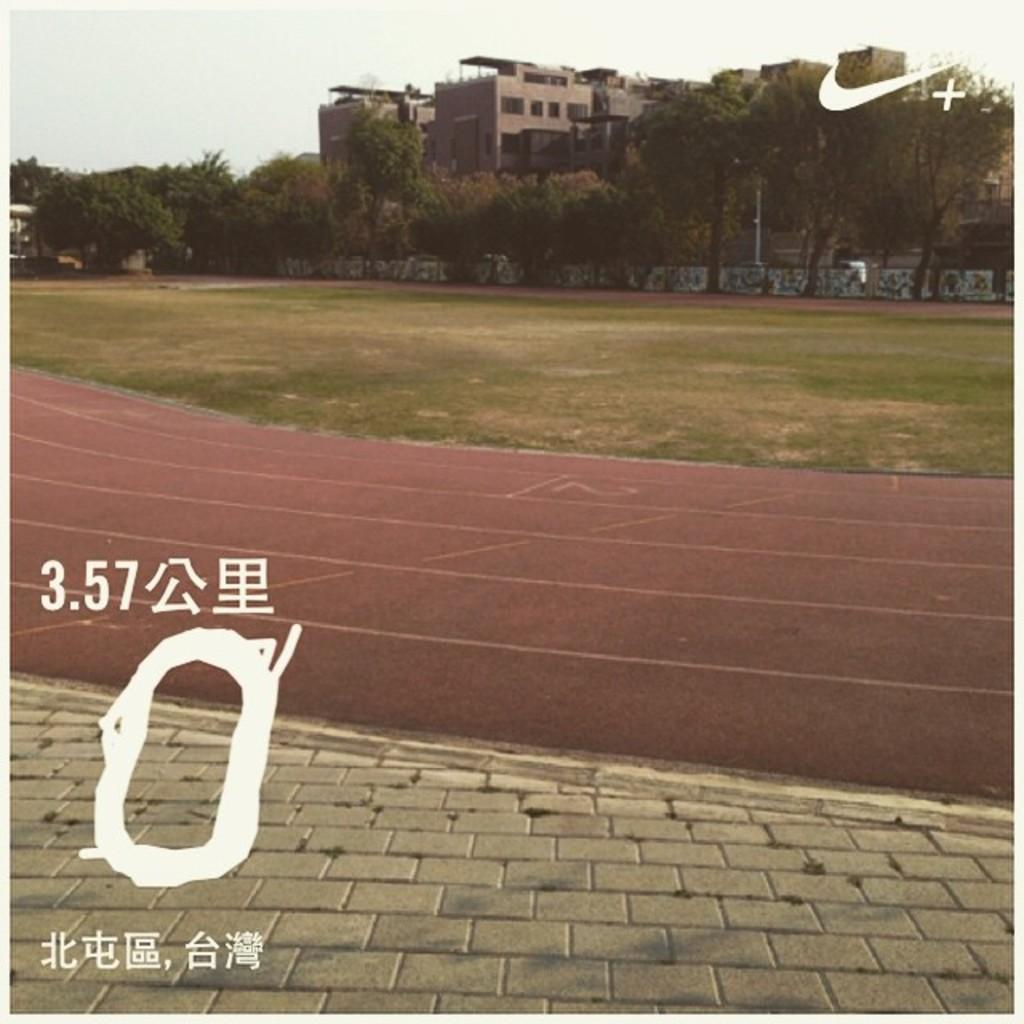What type of pathway is present in the image? There is a road in the image. What can be seen beneath the road? The ground is visible in the image. What type of vegetation is near the road? There are trees in the image, and they are located near the road. What structure is present in the image? There is a wall in the image. What type of man-made structures can be seen in the image? There are buildings in the image. What part of the natural environment is visible in the image? The sky is visible in the background of the image. Can you see an airplane flying over the road in the image? No, there is no airplane visible in the image. 